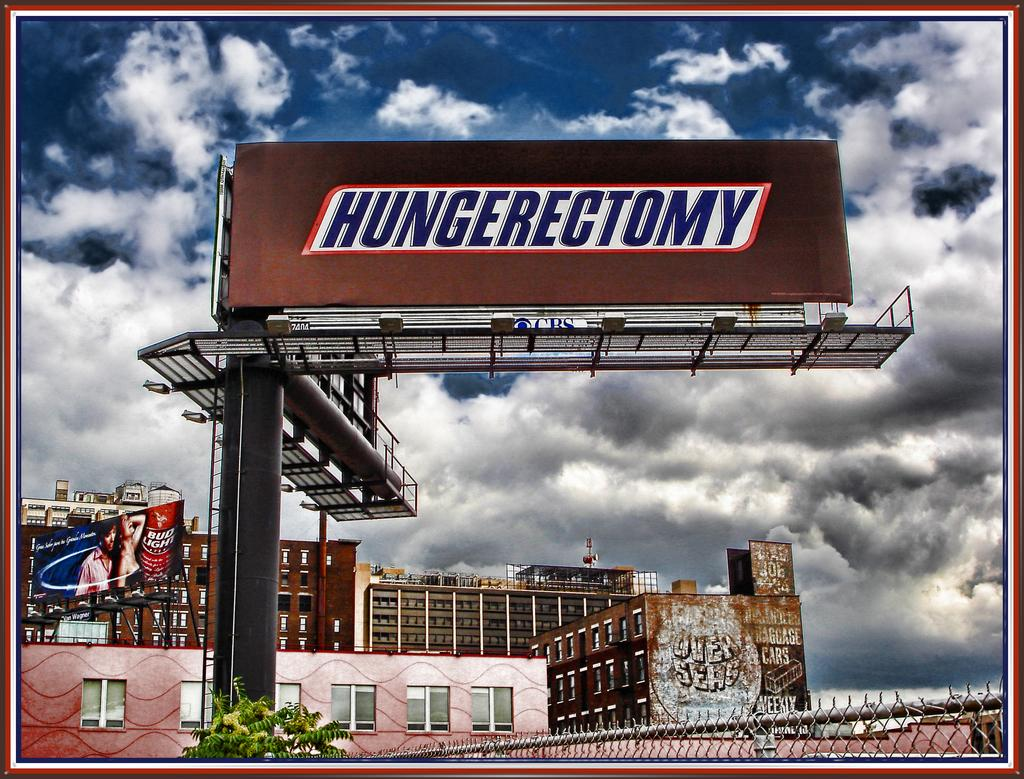<image>
Summarize the visual content of the image. A billboard for Snickers advises people have a hungerectomy. 